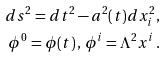Convert formula to latex. <formula><loc_0><loc_0><loc_500><loc_500>d s ^ { 2 } = d t ^ { 2 } - a ^ { 2 } ( t ) d x _ { i } ^ { 2 } , \\ \phi ^ { 0 } = \phi ( t ) \, , \, \phi ^ { i } = \Lambda ^ { 2 } x ^ { i } \, .</formula> 